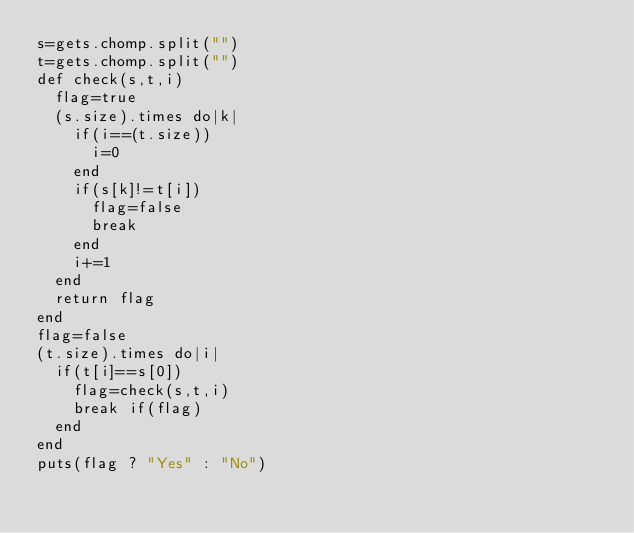<code> <loc_0><loc_0><loc_500><loc_500><_Ruby_>s=gets.chomp.split("")
t=gets.chomp.split("")
def check(s,t,i)
	flag=true
	(s.size).times do|k|
		if(i==(t.size))
			i=0
		end
		if(s[k]!=t[i])
			flag=false
			break
		end
		i+=1
	end	
	return flag
end
flag=false
(t.size).times do|i|
	if(t[i]==s[0])
		flag=check(s,t,i)
		break if(flag)
	end
end
puts(flag ? "Yes" : "No")</code> 